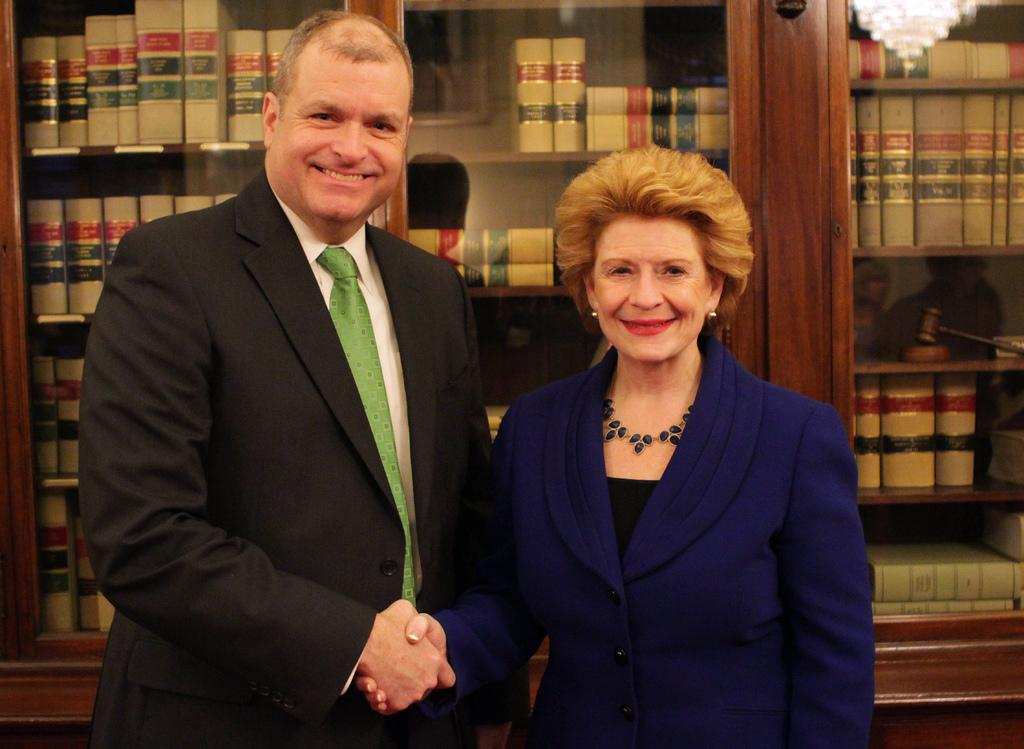Who are the people in the foreground of the image? There is a man and a woman in the foreground of the image. What can be seen in the background of the image? Bookshelves and books are visible in the background of the image. Is there any lighting fixture visible in the image? There might be a chandelier in the top right corner of the image. What type of cheese is being served on the plate in the image? There is no plate or cheese present in the image. How many cherries are on the woman's hat in the image? There is no hat or cherries present in the image. 